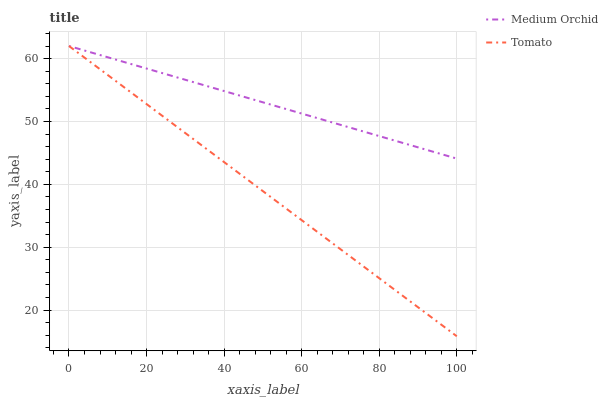Does Tomato have the minimum area under the curve?
Answer yes or no. Yes. Does Medium Orchid have the maximum area under the curve?
Answer yes or no. Yes. Does Medium Orchid have the minimum area under the curve?
Answer yes or no. No. Is Medium Orchid the smoothest?
Answer yes or no. Yes. Is Tomato the roughest?
Answer yes or no. Yes. Is Medium Orchid the roughest?
Answer yes or no. No. Does Tomato have the lowest value?
Answer yes or no. Yes. Does Medium Orchid have the lowest value?
Answer yes or no. No. Does Medium Orchid have the highest value?
Answer yes or no. Yes. Does Medium Orchid intersect Tomato?
Answer yes or no. Yes. Is Medium Orchid less than Tomato?
Answer yes or no. No. Is Medium Orchid greater than Tomato?
Answer yes or no. No. 